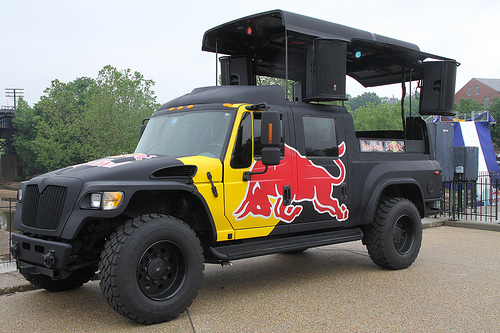<image>
Is there a truck under the bull? No. The truck is not positioned under the bull. The vertical relationship between these objects is different. Is there a truck behind the tire? No. The truck is not behind the tire. From this viewpoint, the truck appears to be positioned elsewhere in the scene. 